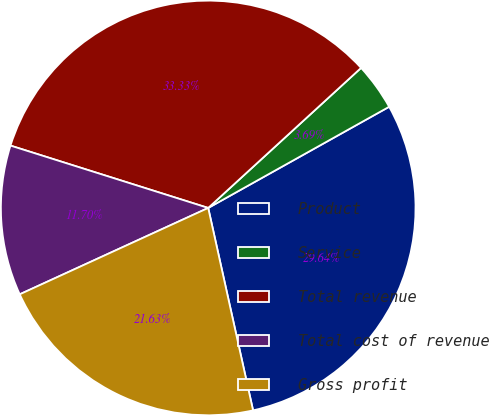<chart> <loc_0><loc_0><loc_500><loc_500><pie_chart><fcel>Product<fcel>Service<fcel>Total revenue<fcel>Total cost of revenue<fcel>Gross profit<nl><fcel>29.64%<fcel>3.69%<fcel>33.33%<fcel>11.7%<fcel>21.63%<nl></chart> 